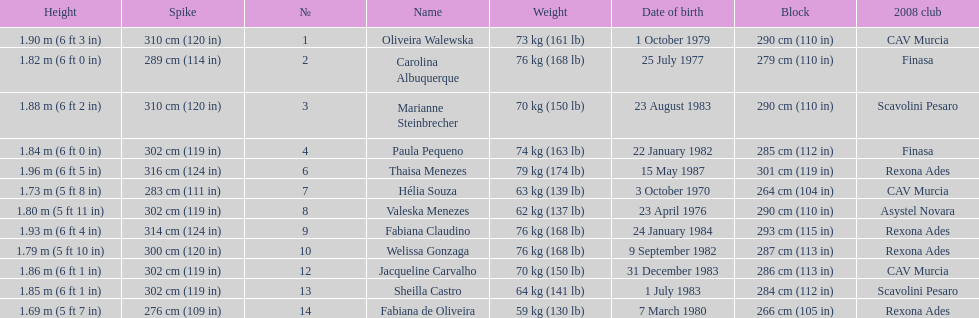Which player is the shortest at only 5 ft 7 in? Fabiana de Oliveira. Could you parse the entire table as a dict? {'header': ['Height', 'Spike', '№', 'Name', 'Weight', 'Date of birth', 'Block', '2008 club'], 'rows': [['1.90\xa0m (6\xa0ft 3\xa0in)', '310\xa0cm (120\xa0in)', '1', 'Oliveira Walewska', '73\xa0kg (161\xa0lb)', '1 October 1979', '290\xa0cm (110\xa0in)', 'CAV Murcia'], ['1.82\xa0m (6\xa0ft 0\xa0in)', '289\xa0cm (114\xa0in)', '2', 'Carolina Albuquerque', '76\xa0kg (168\xa0lb)', '25 July 1977', '279\xa0cm (110\xa0in)', 'Finasa'], ['1.88\xa0m (6\xa0ft 2\xa0in)', '310\xa0cm (120\xa0in)', '3', 'Marianne Steinbrecher', '70\xa0kg (150\xa0lb)', '23 August 1983', '290\xa0cm (110\xa0in)', 'Scavolini Pesaro'], ['1.84\xa0m (6\xa0ft 0\xa0in)', '302\xa0cm (119\xa0in)', '4', 'Paula Pequeno', '74\xa0kg (163\xa0lb)', '22 January 1982', '285\xa0cm (112\xa0in)', 'Finasa'], ['1.96\xa0m (6\xa0ft 5\xa0in)', '316\xa0cm (124\xa0in)', '6', 'Thaisa Menezes', '79\xa0kg (174\xa0lb)', '15 May 1987', '301\xa0cm (119\xa0in)', 'Rexona Ades'], ['1.73\xa0m (5\xa0ft 8\xa0in)', '283\xa0cm (111\xa0in)', '7', 'Hélia Souza', '63\xa0kg (139\xa0lb)', '3 October 1970', '264\xa0cm (104\xa0in)', 'CAV Murcia'], ['1.80\xa0m (5\xa0ft 11\xa0in)', '302\xa0cm (119\xa0in)', '8', 'Valeska Menezes', '62\xa0kg (137\xa0lb)', '23 April 1976', '290\xa0cm (110\xa0in)', 'Asystel Novara'], ['1.93\xa0m (6\xa0ft 4\xa0in)', '314\xa0cm (124\xa0in)', '9', 'Fabiana Claudino', '76\xa0kg (168\xa0lb)', '24 January 1984', '293\xa0cm (115\xa0in)', 'Rexona Ades'], ['1.79\xa0m (5\xa0ft 10\xa0in)', '300\xa0cm (120\xa0in)', '10', 'Welissa Gonzaga', '76\xa0kg (168\xa0lb)', '9 September 1982', '287\xa0cm (113\xa0in)', 'Rexona Ades'], ['1.86\xa0m (6\xa0ft 1\xa0in)', '302\xa0cm (119\xa0in)', '12', 'Jacqueline Carvalho', '70\xa0kg (150\xa0lb)', '31 December 1983', '286\xa0cm (113\xa0in)', 'CAV Murcia'], ['1.85\xa0m (6\xa0ft 1\xa0in)', '302\xa0cm (119\xa0in)', '13', 'Sheilla Castro', '64\xa0kg (141\xa0lb)', '1 July 1983', '284\xa0cm (112\xa0in)', 'Scavolini Pesaro'], ['1.69\xa0m (5\xa0ft 7\xa0in)', '276\xa0cm (109\xa0in)', '14', 'Fabiana de Oliveira', '59\xa0kg (130\xa0lb)', '7 March 1980', '266\xa0cm (105\xa0in)', 'Rexona Ades']]} 